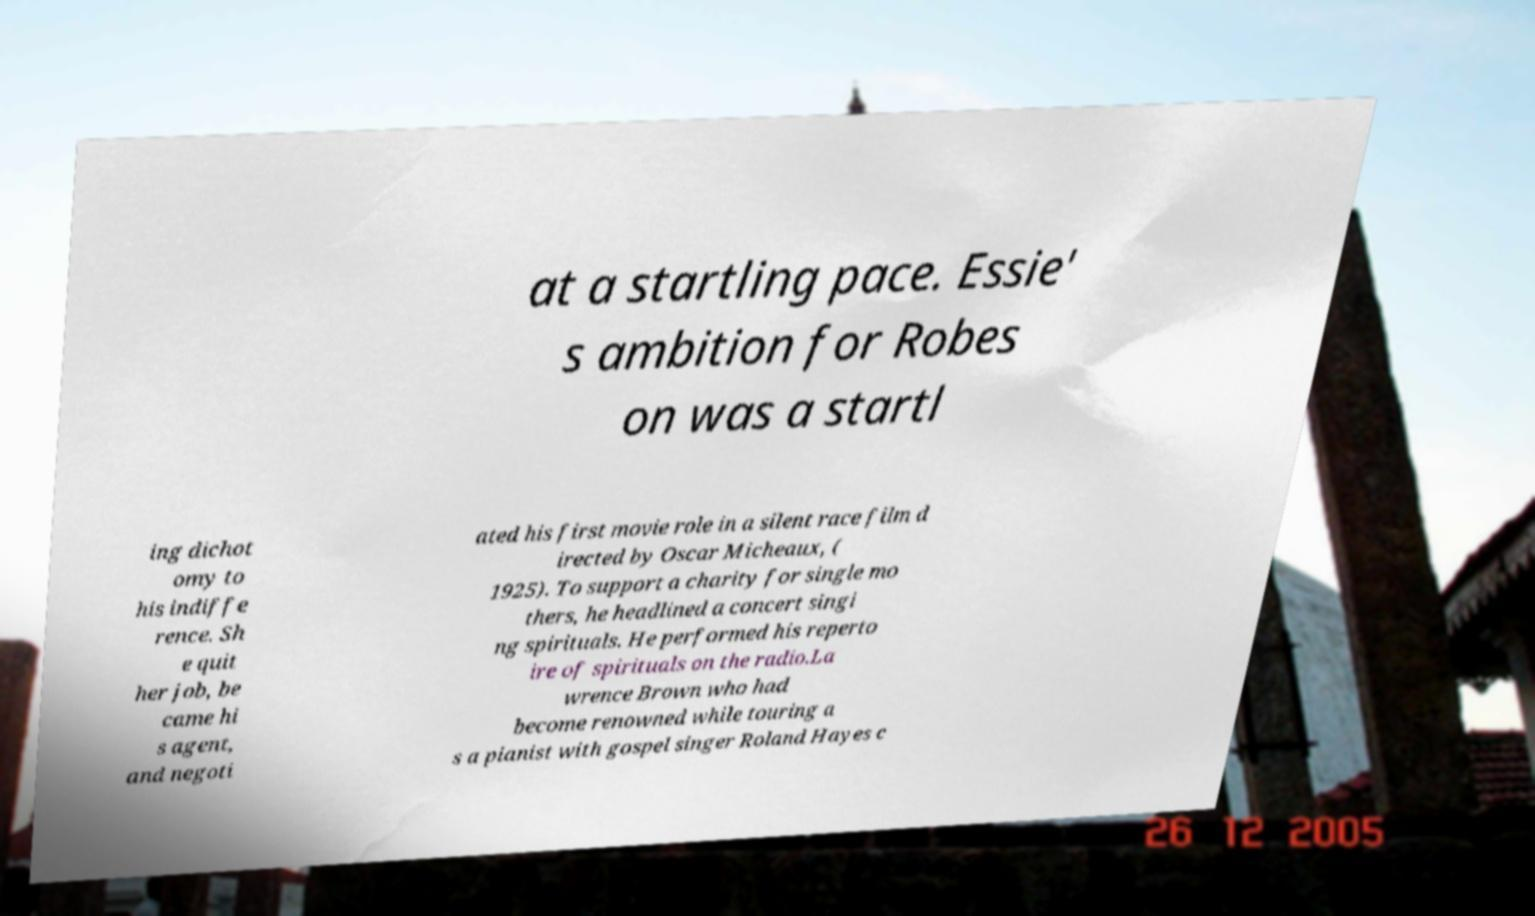What messages or text are displayed in this image? I need them in a readable, typed format. at a startling pace. Essie' s ambition for Robes on was a startl ing dichot omy to his indiffe rence. Sh e quit her job, be came hi s agent, and negoti ated his first movie role in a silent race film d irected by Oscar Micheaux, ( 1925). To support a charity for single mo thers, he headlined a concert singi ng spirituals. He performed his reperto ire of spirituals on the radio.La wrence Brown who had become renowned while touring a s a pianist with gospel singer Roland Hayes c 